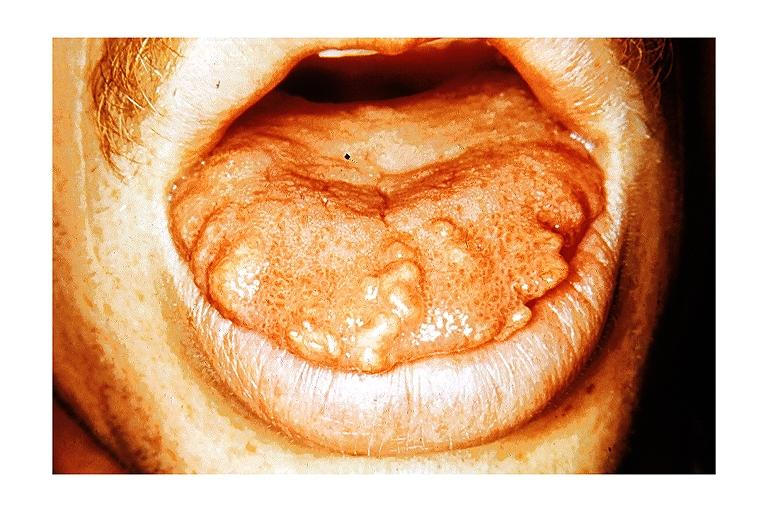does marked show multiple endocrine neoplasia type iib-macroglossia?
Answer the question using a single word or phrase. No 